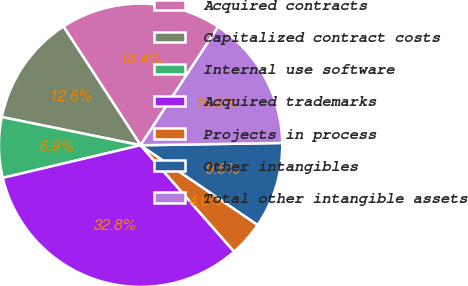Convert chart. <chart><loc_0><loc_0><loc_500><loc_500><pie_chart><fcel>Acquired contracts<fcel>Capitalized contract costs<fcel>Internal use software<fcel>Acquired trademarks<fcel>Projects in process<fcel>Other intangibles<fcel>Total other intangible assets<nl><fcel>18.39%<fcel>12.64%<fcel>6.89%<fcel>32.78%<fcel>4.01%<fcel>9.77%<fcel>15.52%<nl></chart> 